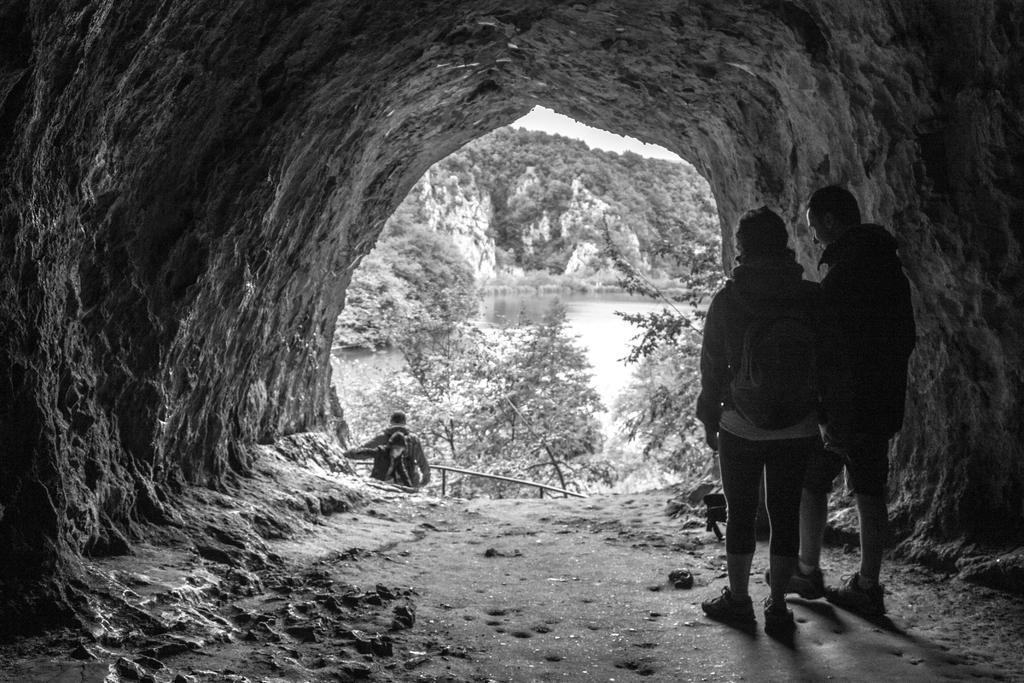Where is the image taken? The image is taken inside a cave. How many persons are visible in the image? There are three persons in the image. What is located on the left side of the image? There is a metal rod, trees, a water body, the sky, and other unspecified objects on the left side of the image. Can you describe the people in the image? There are two persons on the right side of the image and one person on the left side of the image. What type of bag is the achiever holding in the image? There is no achiever or bag present in the image. What is the grandfather doing in the image? There is no grandfather present in the image. 